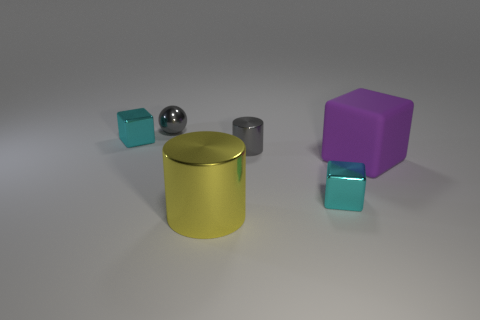Is there any pattern to the arrangement of objects on the surface? The objects appear to be placed randomly, with no discernible pattern. We see a mix of shapes and materials scattered with ample space between them. 